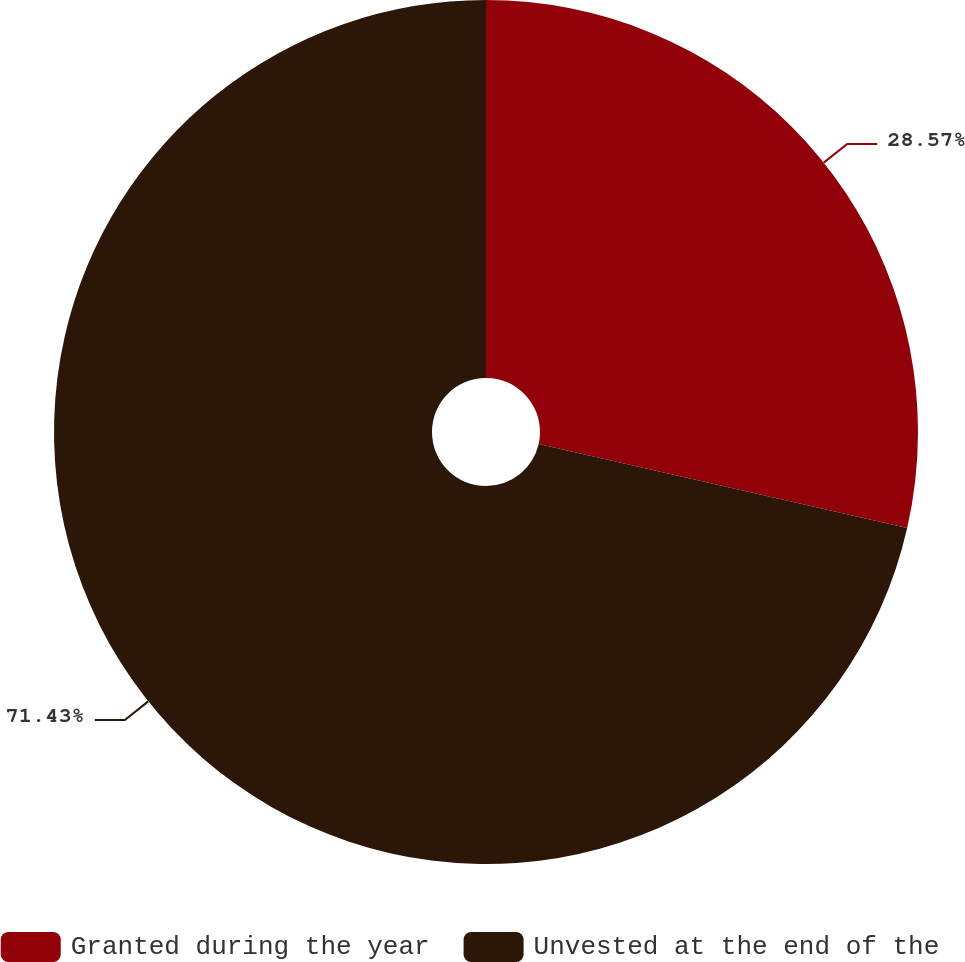Convert chart. <chart><loc_0><loc_0><loc_500><loc_500><pie_chart><fcel>Granted during the year<fcel>Unvested at the end of the<nl><fcel>28.57%<fcel>71.43%<nl></chart> 